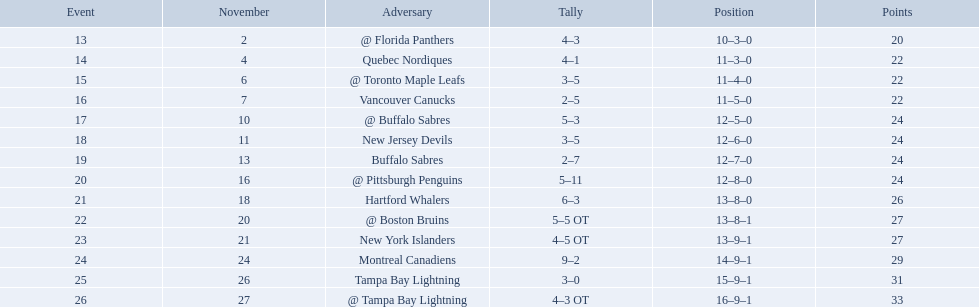Who did the philadelphia flyers play in game 17? @ Buffalo Sabres. What was the score of the november 10th game against the buffalo sabres? 5–3. Which team in the atlantic division had less points than the philadelphia flyers? Tampa Bay Lightning. What were the scores? @ Florida Panthers, 4–3, Quebec Nordiques, 4–1, @ Toronto Maple Leafs, 3–5, Vancouver Canucks, 2–5, @ Buffalo Sabres, 5–3, New Jersey Devils, 3–5, Buffalo Sabres, 2–7, @ Pittsburgh Penguins, 5–11, Hartford Whalers, 6–3, @ Boston Bruins, 5–5 OT, New York Islanders, 4–5 OT, Montreal Canadiens, 9–2, Tampa Bay Lightning, 3–0, @ Tampa Bay Lightning, 4–3 OT. What score was the closest? New York Islanders, 4–5 OT. What team had that score? New York Islanders. 